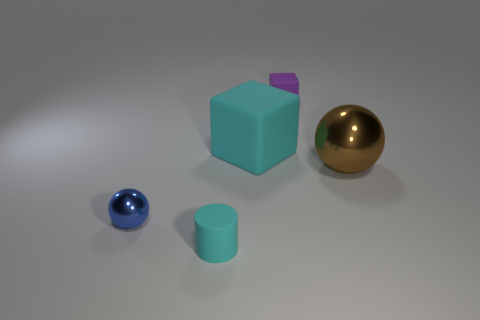The other thing that is the same shape as the small purple thing is what color?
Your answer should be very brief. Cyan. There is a tiny object that is both behind the cyan matte cylinder and to the right of the blue metal object; what material is it made of?
Keep it short and to the point. Rubber. There is a ball that is to the right of the blue thing; does it have the same size as the blue object?
Offer a terse response. No. What material is the purple thing?
Offer a terse response. Rubber. What is the color of the metal object that is to the right of the blue object?
Your response must be concise. Brown. How many big things are rubber cylinders or purple objects?
Your response must be concise. 0. Is the color of the thing that is in front of the small metallic thing the same as the big object that is left of the big brown thing?
Provide a succinct answer. Yes. How many other things are there of the same color as the large cube?
Offer a terse response. 1. How many purple objects are either large balls or tiny blocks?
Make the answer very short. 1. There is a small purple thing; is its shape the same as the cyan object that is on the right side of the small cyan matte cylinder?
Ensure brevity in your answer.  Yes. 